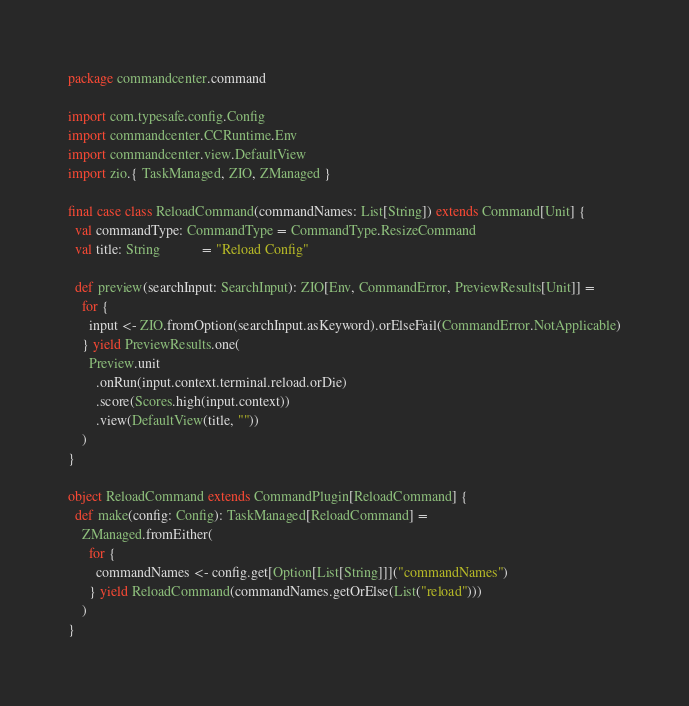Convert code to text. <code><loc_0><loc_0><loc_500><loc_500><_Scala_>package commandcenter.command

import com.typesafe.config.Config
import commandcenter.CCRuntime.Env
import commandcenter.view.DefaultView
import zio.{ TaskManaged, ZIO, ZManaged }

final case class ReloadCommand(commandNames: List[String]) extends Command[Unit] {
  val commandType: CommandType = CommandType.ResizeCommand
  val title: String            = "Reload Config"

  def preview(searchInput: SearchInput): ZIO[Env, CommandError, PreviewResults[Unit]] =
    for {
      input <- ZIO.fromOption(searchInput.asKeyword).orElseFail(CommandError.NotApplicable)
    } yield PreviewResults.one(
      Preview.unit
        .onRun(input.context.terminal.reload.orDie)
        .score(Scores.high(input.context))
        .view(DefaultView(title, ""))
    )
}

object ReloadCommand extends CommandPlugin[ReloadCommand] {
  def make(config: Config): TaskManaged[ReloadCommand] =
    ZManaged.fromEither(
      for {
        commandNames <- config.get[Option[List[String]]]("commandNames")
      } yield ReloadCommand(commandNames.getOrElse(List("reload")))
    )
}
</code> 